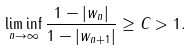Convert formula to latex. <formula><loc_0><loc_0><loc_500><loc_500>\liminf _ { n \rightarrow \infty } \frac { 1 - | w _ { n } | } { 1 - | w _ { n + 1 } | } \geq C > 1 .</formula> 